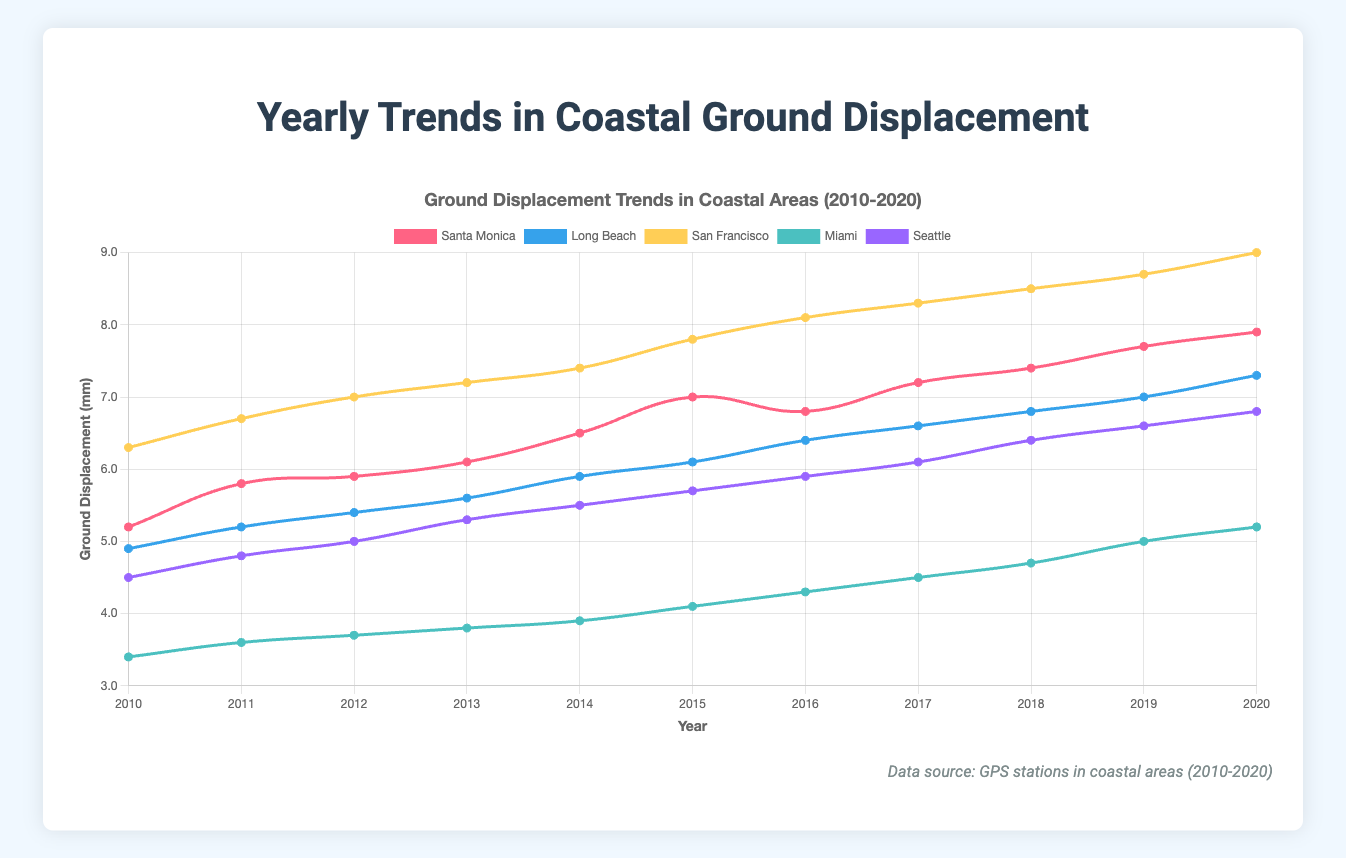What's the trend of ground displacement in Long Beach from 2010 to 2020? To find the trend, observe the data points for Long Beach each year. They start at 4.9 mm in 2010 and end at 7.3 mm in 2020, indicating a steady increase.
Answer: Steady increase Which GPS station had the highest ground displacement in 2020? By looking at the end points of the curves in 2020, San Francisco shows the highest value at 9.0 mm.
Answer: San Francisco What is the difference in ground displacement between Miami and Seattle in 2020? The 2020 ground displacement for Miami is 5.2 mm and for Seattle is 6.8 mm. Subtract Miami's value from Seattle's value: 6.8 mm - 5.2 mm = 1.6 mm.
Answer: 1.6 mm Which city shows the least ground displacement over the years covered in the chart? The least ground displacement can be identified by checking the lowest curve on the chart during the entire time period. Miami consistently shows the lowest values each year.
Answer: Miami What is the average yearly ground displacement for Santa Monica between 2010 and 2020? Add the yearly data points for Santa Monica: 5.2 + 5.8 + 5.9 + 6.1 + 6.5 + 7.0 + 6.8 + 7.2 + 7.4 + 7.7 + 7.9 = 73.5 mm. Divide by the number of years (11): 73.5 / 11 = 6.68 mm.
Answer: 6.68 mm Which GPS station shows the greatest increase in ground displacement from 2010 to 2020? Calculate the difference in ground displacement from 2010 to 2020 for each station: 
Santa Monica: 7.9 - 5.2 = 2.7 mm,
Long Beach: 7.3 - 4.9 = 2.4 mm,
San Francisco: 9.0 - 6.3 = 2.7 mm,
Miami: 5.2 - 3.4 = 1.8 mm,
Seattle: 6.8 - 4.5 = 2.3 mm.
San Francisco and Santa Monica show the greatest increase of 2.7 mm.
Answer: San Francisco and Santa Monica How many years did San Francisco have higher ground displacement than Long Beach? Compare the yearly data points for San Francisco and Long Beach from each year:
2010: 6.3 > 4.9,
2011: 6.7 > 5.2,
2012: 7.0 > 5.4,
2013: 7.2 > 5.6,
2014: 7.4 > 5.9,
2015: 7.8 > 6.1,
2016: 8.1 > 6.4,
2017: 8.3 > 6.6,
2018: 8.5 > 6.8,
2019: 8.7 > 7.0,
2020: 9.0 > 7.3.
San Francisco had higher ground displacement every year, so 11 years total.
Answer: 11 years If the trends continue, which city is likely to have the highest ground displacement in 2021? San Francisco's steady trend of increase in ground displacement is the highest among all cities. Based on the observed trends, San Francisco is likely to continue having the highest value.
Answer: San Francisco 